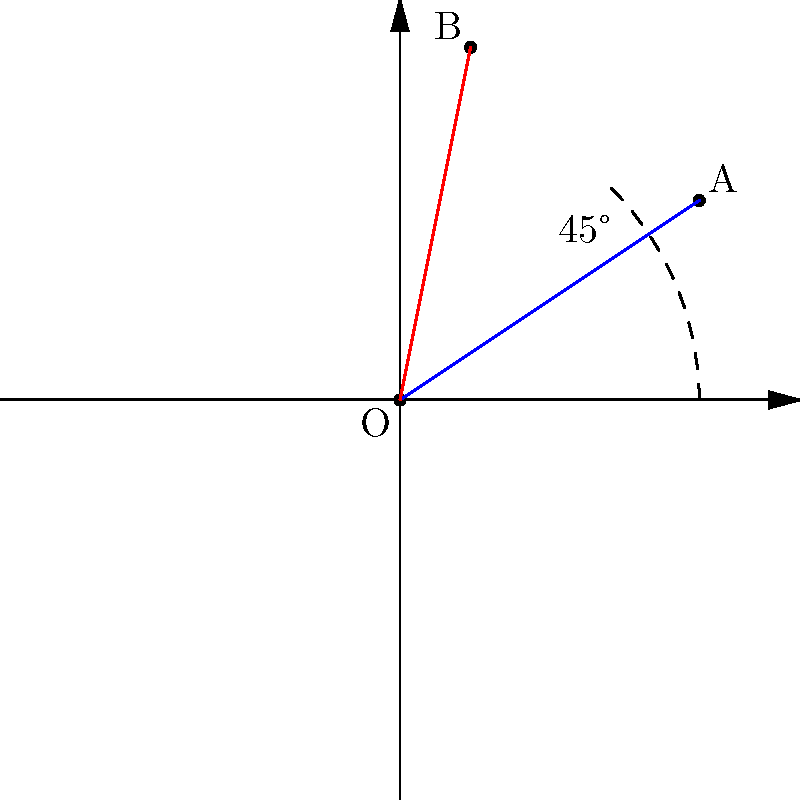As a TikTok content creator, you're adapting your content for different audience segments. This can be represented by rotating a point around the origin in a coordinate system. If point A(3,2) represents your current content strategy, and you rotate it 45° counterclockwise to reach a new audience (point B), what are the coordinates of point B? To find the coordinates of point B after rotating point A(3,2) by 45° counterclockwise around the origin, we can use the rotation matrix:

$$\begin{pmatrix} \cos\theta & -\sin\theta \\ \sin\theta & \cos\theta \end{pmatrix}$$

Where $\theta = 45°$. Let's follow these steps:

1) First, we need the values of $\cos 45°$ and $\sin 45°$:
   $\cos 45° = \sin 45° = \frac{\sqrt{2}}{2}$

2) Now, we can set up our rotation matrix:
   $$\begin{pmatrix} \frac{\sqrt{2}}{2} & -\frac{\sqrt{2}}{2} \\ \frac{\sqrt{2}}{2} & \frac{\sqrt{2}}{2} \end{pmatrix}$$

3) We multiply this matrix by the coordinates of point A:
   $$\begin{pmatrix} \frac{\sqrt{2}}{2} & -\frac{\sqrt{2}}{2} \\ \frac{\sqrt{2}}{2} & \frac{\sqrt{2}}{2} \end{pmatrix} \begin{pmatrix} 3 \\ 2 \end{pmatrix}$$

4) Carrying out the matrix multiplication:
   $$\begin{pmatrix} \frac{\sqrt{2}}{2}(3) - \frac{\sqrt{2}}{2}(2) \\ \frac{\sqrt{2}}{2}(3) + \frac{\sqrt{2}}{2}(2) \end{pmatrix}$$

5) Simplifying:
   $$\begin{pmatrix} \frac{3\sqrt{2}}{2} - \frac{2\sqrt{2}}{2} \\ \frac{3\sqrt{2}}{2} + \frac{2\sqrt{2}}{2} \end{pmatrix} = \begin{pmatrix} \frac{\sqrt{2}}{2} \\ \frac{5\sqrt{2}}{2} \end{pmatrix}$$

Therefore, the coordinates of point B are $(\frac{\sqrt{2}}{2}, \frac{5\sqrt{2}}{2})$.
Answer: $(\frac{\sqrt{2}}{2}, \frac{5\sqrt{2}}{2})$ 